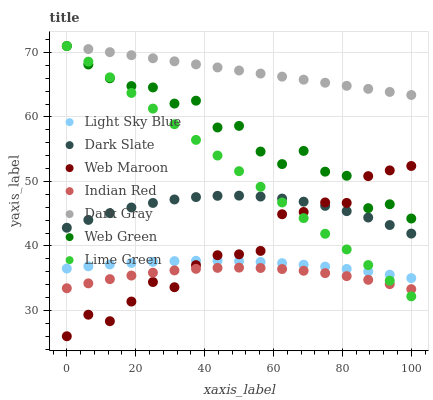Does Indian Red have the minimum area under the curve?
Answer yes or no. Yes. Does Dark Gray have the maximum area under the curve?
Answer yes or no. Yes. Does Web Green have the minimum area under the curve?
Answer yes or no. No. Does Web Green have the maximum area under the curve?
Answer yes or no. No. Is Dark Gray the smoothest?
Answer yes or no. Yes. Is Web Green the roughest?
Answer yes or no. Yes. Is Web Green the smoothest?
Answer yes or no. No. Is Dark Gray the roughest?
Answer yes or no. No. Does Web Maroon have the lowest value?
Answer yes or no. Yes. Does Web Green have the lowest value?
Answer yes or no. No. Does Lime Green have the highest value?
Answer yes or no. Yes. Does Dark Slate have the highest value?
Answer yes or no. No. Is Light Sky Blue less than Dark Gray?
Answer yes or no. Yes. Is Dark Gray greater than Indian Red?
Answer yes or no. Yes. Does Web Green intersect Dark Gray?
Answer yes or no. Yes. Is Web Green less than Dark Gray?
Answer yes or no. No. Is Web Green greater than Dark Gray?
Answer yes or no. No. Does Light Sky Blue intersect Dark Gray?
Answer yes or no. No. 